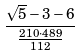Convert formula to latex. <formula><loc_0><loc_0><loc_500><loc_500>\frac { \sqrt { 5 } - 3 - 6 } { \frac { 2 1 0 \cdot 4 8 9 } { 1 1 2 } }</formula> 